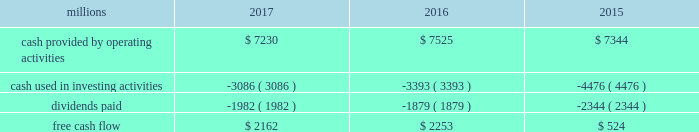Adjusted net income of $ 4.6 billion translated into adjusted earnings of $ 5.79 per diluted share , a best- ever performance .
F0b7 freight revenues 2013 our freight revenues increased 7% ( 7 % ) year-over-year to $ 19.8 billion driven by volume growth of 2% ( 2 % ) , higher fuel surcharge revenue , and core pricing gains .
Growth in frac sand , coal , and intermodal shipments more than offset declines in grain , crude oil , finished vehicles , and rock shipments .
F0b7 fuel prices 2013 our average price of diesel fuel in 2017 was $ 1.81 per gallon , an increase of 22% ( 22 % ) from 2016 , as both crude oil and conversion spreads between crude oil and diesel increased in 2017 .
The higher price resulted in increased operating expenses of $ 334 million ( excluding any impact from year- over-year volume growth ) .
Gross-ton miles increased 5% ( 5 % ) , which also drove higher fuel expense .
Our fuel consumption rate , computed as gallons of fuel consumed divided by gross ton-miles in thousands , improved 2% ( 2 % ) .
F0b7 free cash flow 2013 cash generated by operating activities totaled $ 7.2 billion , yielding free cash flow of $ 2.2 billion after reductions of $ 3.1 billion for cash used in investing activities and $ 2 billion in dividends , which included a 10% ( 10 % ) increase in our quarterly dividend per share from $ 0.605 to $ 0.665 declared and paid in the fourth quarter of 2017 .
Free cash flow is defined as cash provided by operating activities less cash used in investing activities and dividends paid .
Free cash flow is not considered a financial measure under gaap by sec regulation g and item 10 of sec regulation s-k and may not be defined and calculated by other companies in the same manner .
We believe free cash flow is important to management and investors in evaluating our financial performance and measures our ability to generate cash without additional external financings .
Free cash flow should be considered in addition to , rather than as a substitute for , cash provided by operating activities .
The table reconciles cash provided by operating activities ( gaap measure ) to free cash flow ( non-gaap measure ) : .
2018 outlook f0b7 safety 2013 operating a safe railroad benefits all our constituents : our employees , customers , shareholders and the communities we serve .
We will continue using a multi-faceted approach to safety , utilizing technology , risk assessment , training and employee engagement , quality control , and targeted capital investments .
We will continue using and expanding the deployment of total safety culture and courage to care throughout our operations , which allows us to identify and implement best practices for employee and operational safety .
We will continue our efforts to increase detection of rail defects ; improve or close crossings ; and educate the public and law enforcement agencies about crossing safety through a combination of our own programs ( including risk assessment strategies ) , industry programs and local community activities across our network .
F0b7 network operations 2013 in 2018 , we will continue to align resources with customer demand , maintain an efficient network , and ensure surge capability of our assets .
F0b7 fuel prices 2013 fuel price projections for crude oil and natural gas continue to fluctuate in the current environment .
We again could see volatile fuel prices during the year , as they are sensitive to global and u.s .
Domestic demand , refining capacity , geopolitical events , weather conditions and other factors .
As prices fluctuate , there will be a timing impact on earnings , as our fuel surcharge programs trail increases or decreases in fuel price by approximately two months .
Lower fuel prices could have a positive impact on the economy by increasing consumer discretionary spending that potentially could increase demand for various consumer products that we transport .
Alternatively , lower fuel prices could likely have a negative impact on other commodities such as coal and domestic drilling-related shipments. .
What was the percentage change in free cash flow from 2016 to 2017? 
Computations: ((2162 - 2253) / 2253)
Answer: -0.04039. 